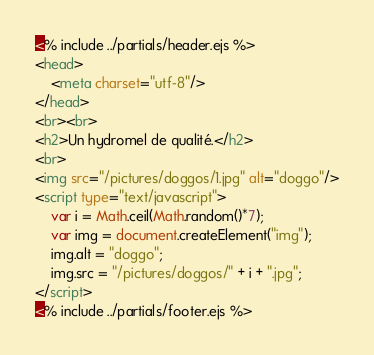Convert code to text. <code><loc_0><loc_0><loc_500><loc_500><_HTML_><% include ../partials/header.ejs %>
<head>
	<meta charset="utf-8"/>
</head>
<br><br>
<h2>Un hydromel de qualité.</h2>
<br>
<img src="/pictures/doggos/1.jpg" alt="doggo"/>
<script type="text/javascript">
	var i = Math.ceil(Math.random()*7);
	var img = document.createElement("img");
	img.alt = "doggo";
	img.src = "/pictures/doggos/" + i + ".jpg";
</script>
<% include ../partials/footer.ejs %>
</code> 